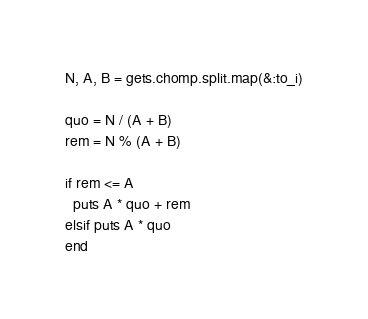Convert code to text. <code><loc_0><loc_0><loc_500><loc_500><_Ruby_>N, A, B = gets.chomp.split.map(&:to_i)

quo = N / (A + B)
rem = N % (A + B)

if rem <= A
  puts A * quo + rem
elsif puts A * quo
end
</code> 